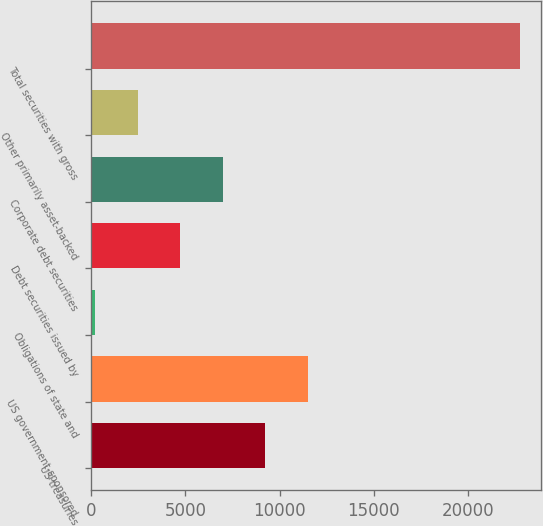Convert chart. <chart><loc_0><loc_0><loc_500><loc_500><bar_chart><fcel>US treasuries<fcel>US government-sponsored<fcel>Obligations of state and<fcel>Debt securities issued by<fcel>Corporate debt securities<fcel>Other primarily asset-backed<fcel>Total securities with gross<nl><fcel>9233<fcel>11482<fcel>237<fcel>4735<fcel>6984<fcel>2486<fcel>22727<nl></chart> 